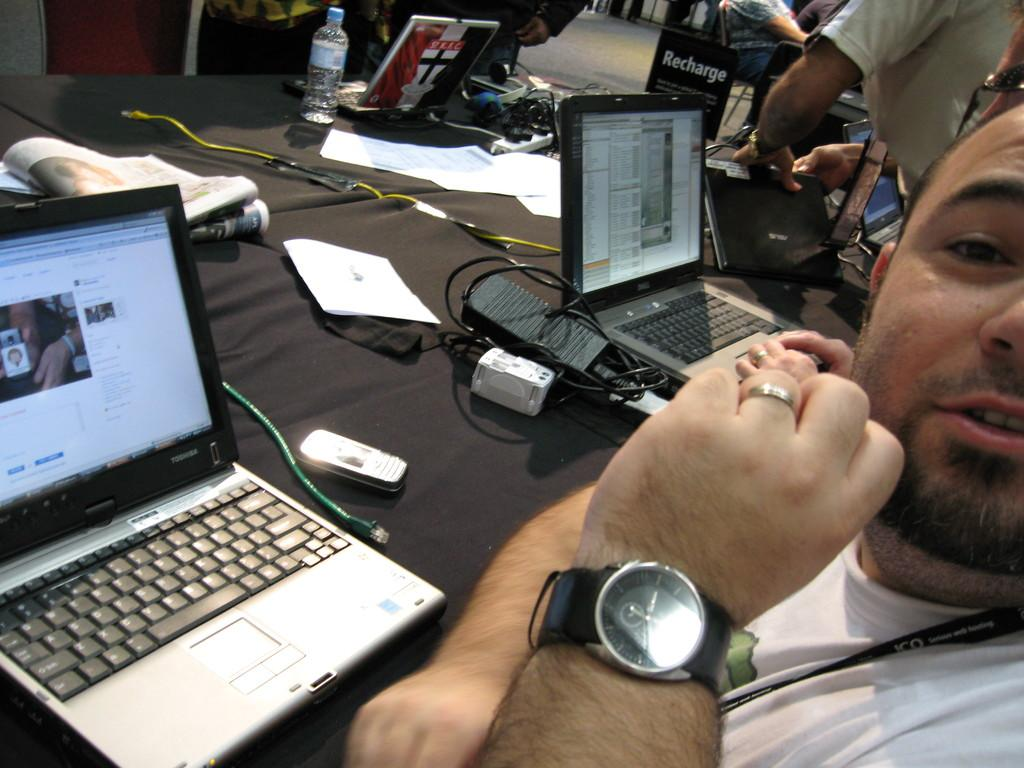<image>
Offer a succinct explanation of the picture presented. A man sits at a desk by a Toshiba branded laptop. 